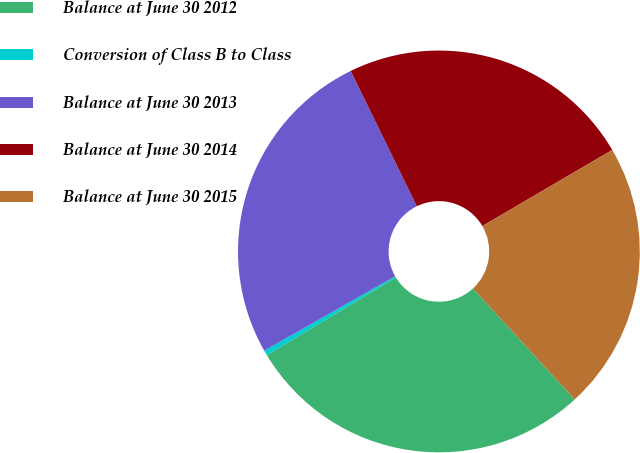<chart> <loc_0><loc_0><loc_500><loc_500><pie_chart><fcel>Balance at June 30 2012<fcel>Conversion of Class B to Class<fcel>Balance at June 30 2013<fcel>Balance at June 30 2014<fcel>Balance at June 30 2015<nl><fcel>28.18%<fcel>0.41%<fcel>25.99%<fcel>23.8%<fcel>21.61%<nl></chart> 